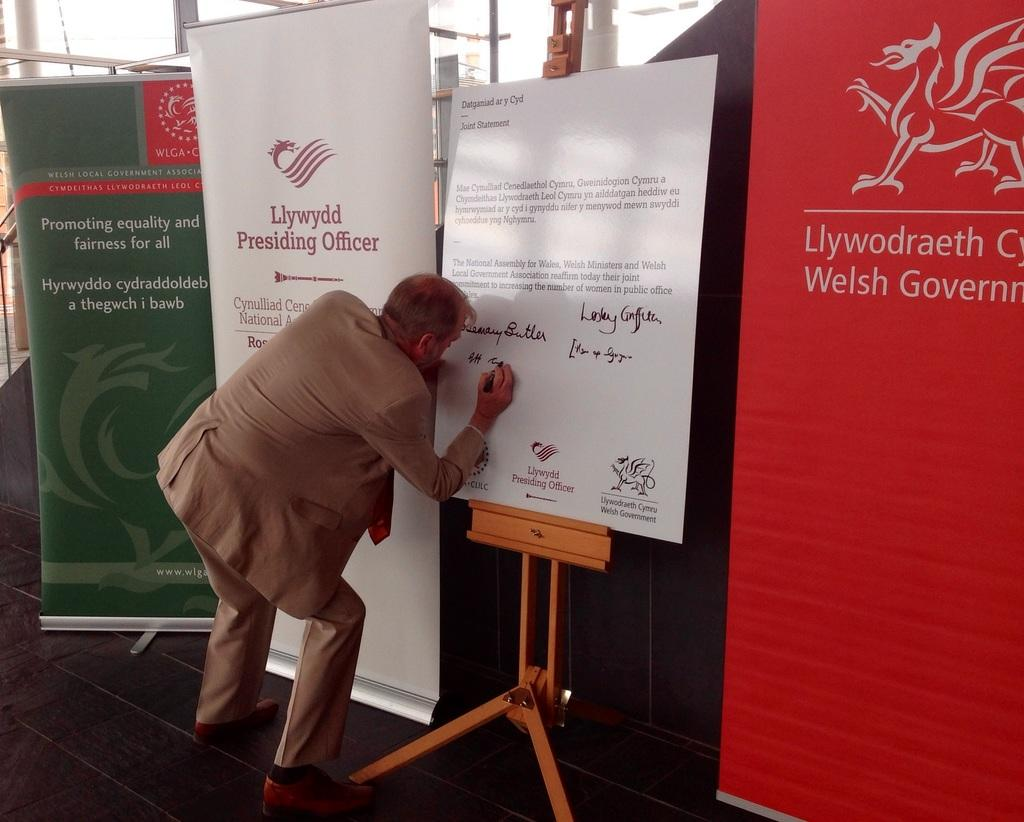What is the person in the image doing? The person is writing on a board with a marker. What else can be seen in the image besides the person writing? There are other boards and stands visible in the background. What is the surface on which the person is standing? There is a floor in the image. What flavor of ice cream is the person eating in the image? There is no ice cream present in the image; the person is writing on a board with a marker. 